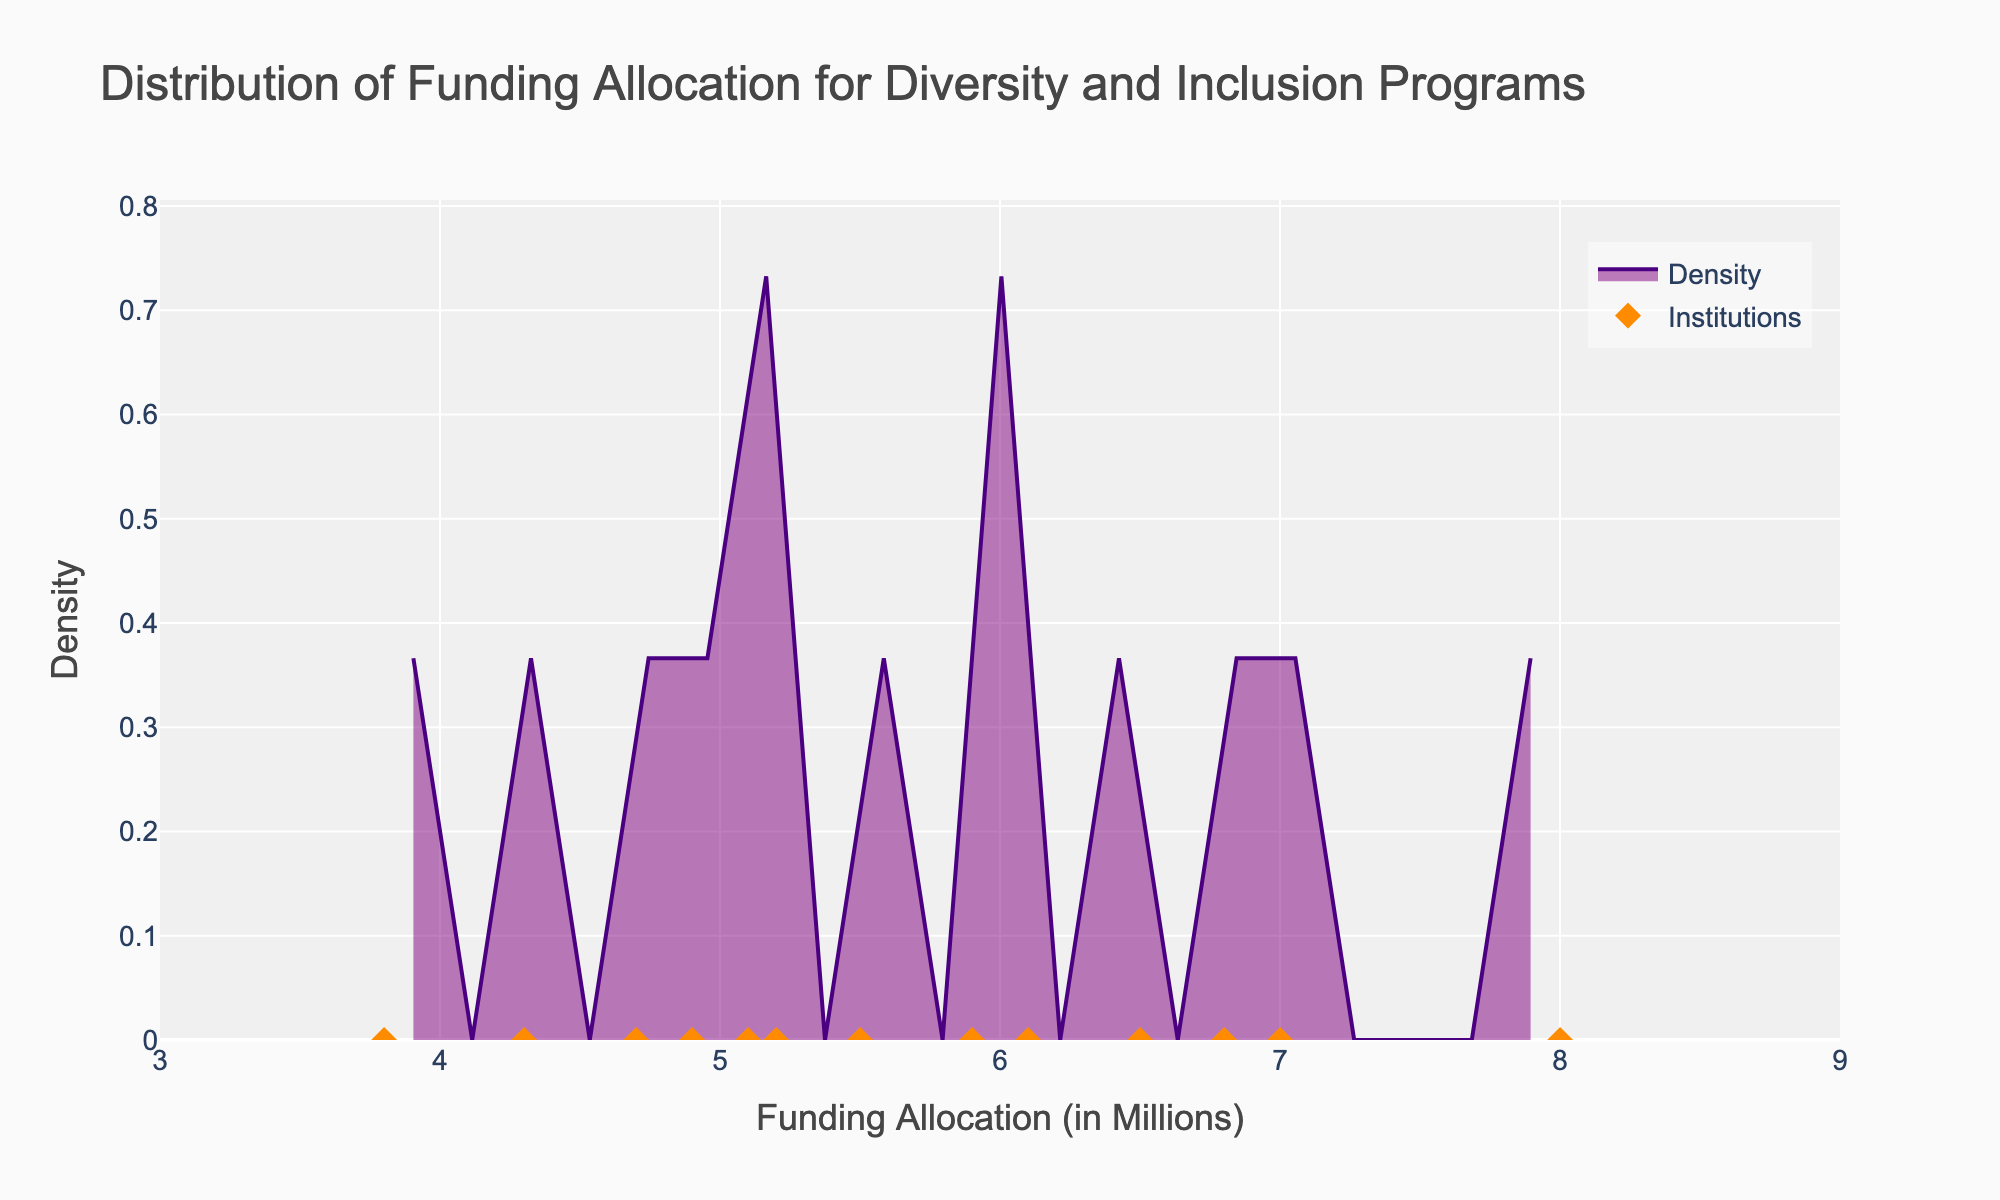How many institutions are represented in the plot? Count the number of individual data points, which represent each institution. There are 13 markers.
Answer: 13 What is the funding allocation range displayed on the x-axis? Observe the x-axis range from the plot. The axis ranges from 3 to 9 million dollars.
Answer: 3 to 9 million dollars What is the title of the plot? Read the title displayed at the top of the plot. It is "Distribution of Funding Allocation for Diversity and Inclusion Programs."
Answer: Distribution of Funding Allocation for Diversity and Inclusion Programs Which institution has the highest funding allocation for diversity and inclusion programs? Look for the highest data point along the x-axis. Howard University is at 8.0 million dollars, the highest allocation.
Answer: Howard University What is the most common funding allocation interval for the institutions? Observe the peak of the density plot, which represents the interval with the highest density. The peak is around the 6 million mark.
Answer: Around 6 million dollars What color represents the density area in the plot? Identify the filled area under the density plot. It is filled with purple with transparency.
Answer: Purple Compare the funding allocation between New York University and Spelman College. Which one receives more? Locate the data points for New York University (5.5 million) and Spelman College (4.9 million) and compare the values. New York University receives more allocation.
Answer: New York University Calculate the difference in funding allocation between Stanford University and University of Texas. The funding allocation for Stanford University is 6.5 million dollars, and for University of Texas, it is 7.0 million dollars. The difference is 7.0 - 6.5 = 0.5 million dollars.
Answer: 0.5 million dollars What is the range of the y-axis density values? Look at the y-axis limits from the plot. The axis ranges from 0 to slightly above 0.15, which is approximately the maximum value shown.
Answer: 0 to 0.165 Identify which institutions have a funding allocation of exactly 5.1 million dollars. Find the data points that are exactly at 5.1 million dollars. Morehouse College has this allocation.
Answer: Morehouse College 